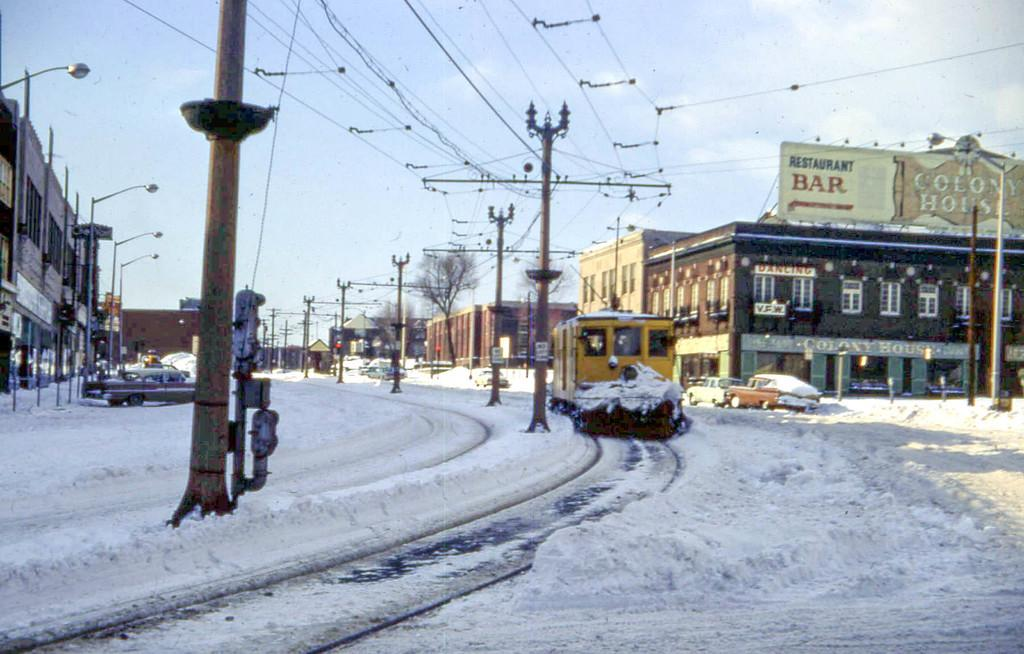<image>
Write a terse but informative summary of the picture. A yellow single car trolley glides by the Colony House restaurant and bar. 